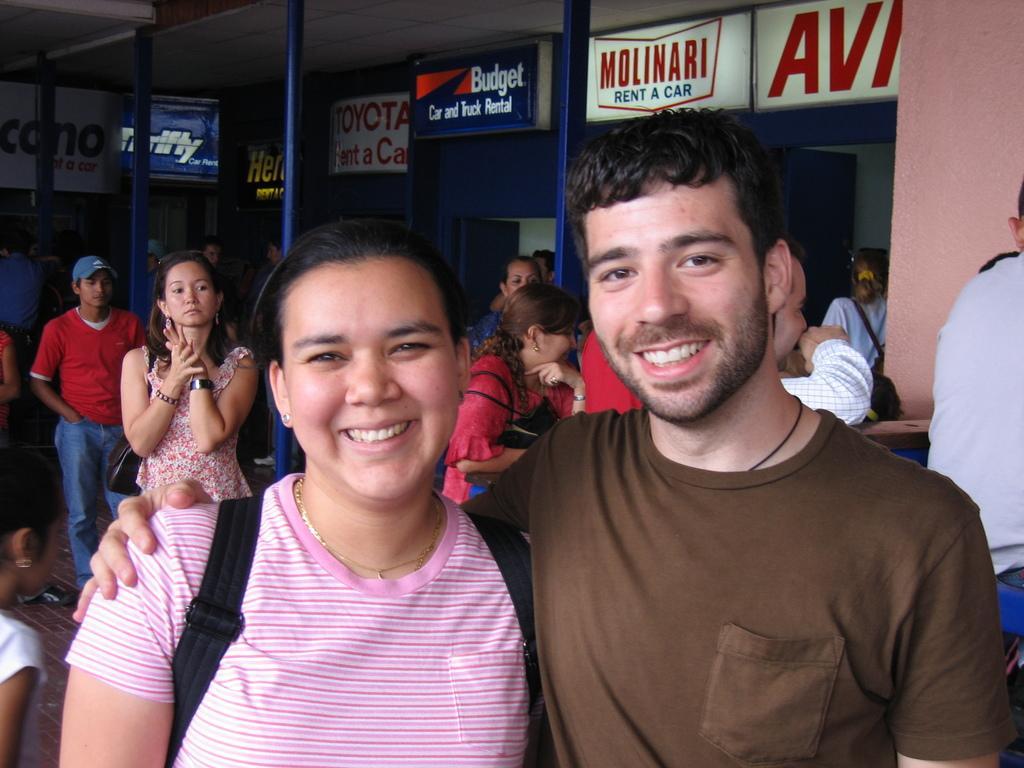Describe this image in one or two sentences. In the picture we can see a man and a woman standing together and they are smiling and woman is wearing a pink T-shirt and man is wearing a brown T-shirt and behind them we can see some people are standing and some people are walking and behind them we can see some stores with some names on it. 